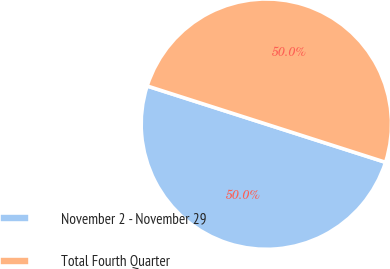<chart> <loc_0><loc_0><loc_500><loc_500><pie_chart><fcel>November 2 - November 29<fcel>Total Fourth Quarter<nl><fcel>50.0%<fcel>50.0%<nl></chart> 